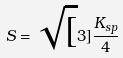<formula> <loc_0><loc_0><loc_500><loc_500>S = \sqrt { [ } 3 ] { \frac { K _ { s p } } { 4 } }</formula> 